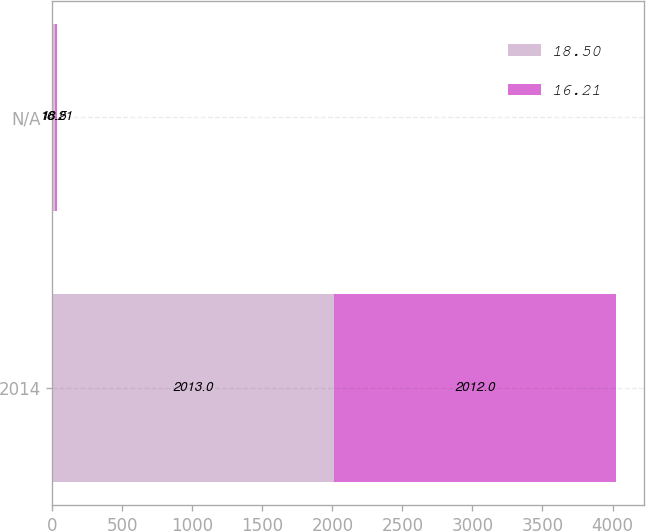<chart> <loc_0><loc_0><loc_500><loc_500><stacked_bar_chart><ecel><fcel>2014<fcel>N/A<nl><fcel>18.5<fcel>2013<fcel>18.5<nl><fcel>16.21<fcel>2012<fcel>16.21<nl></chart> 